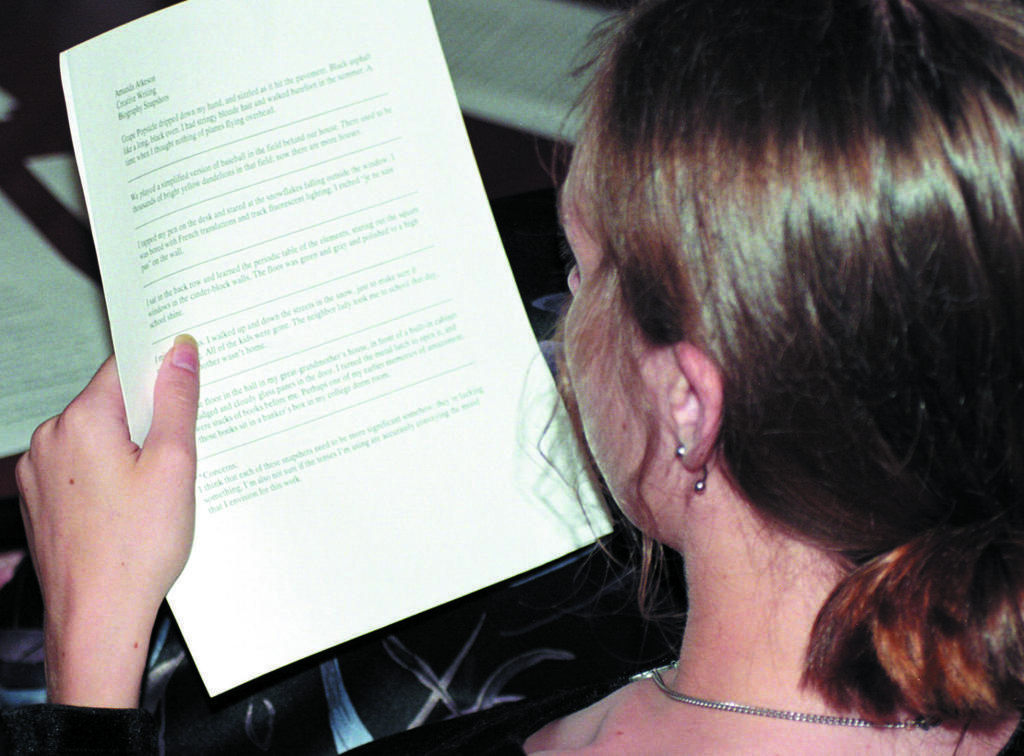Could you give a brief overview of what you see in this image? In this picture we can see a woman and she is holding a paper. 